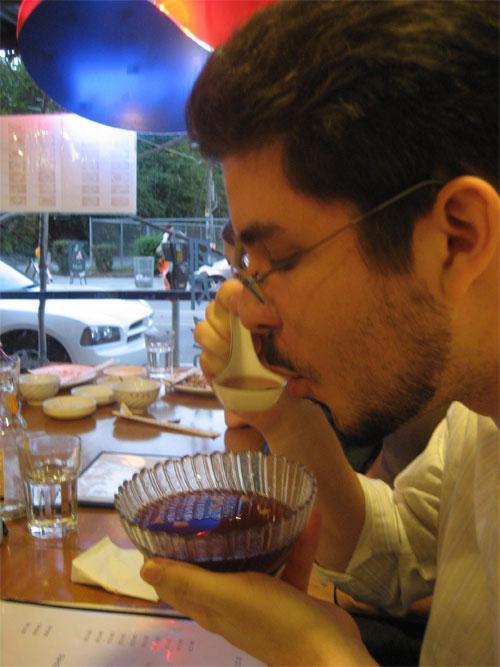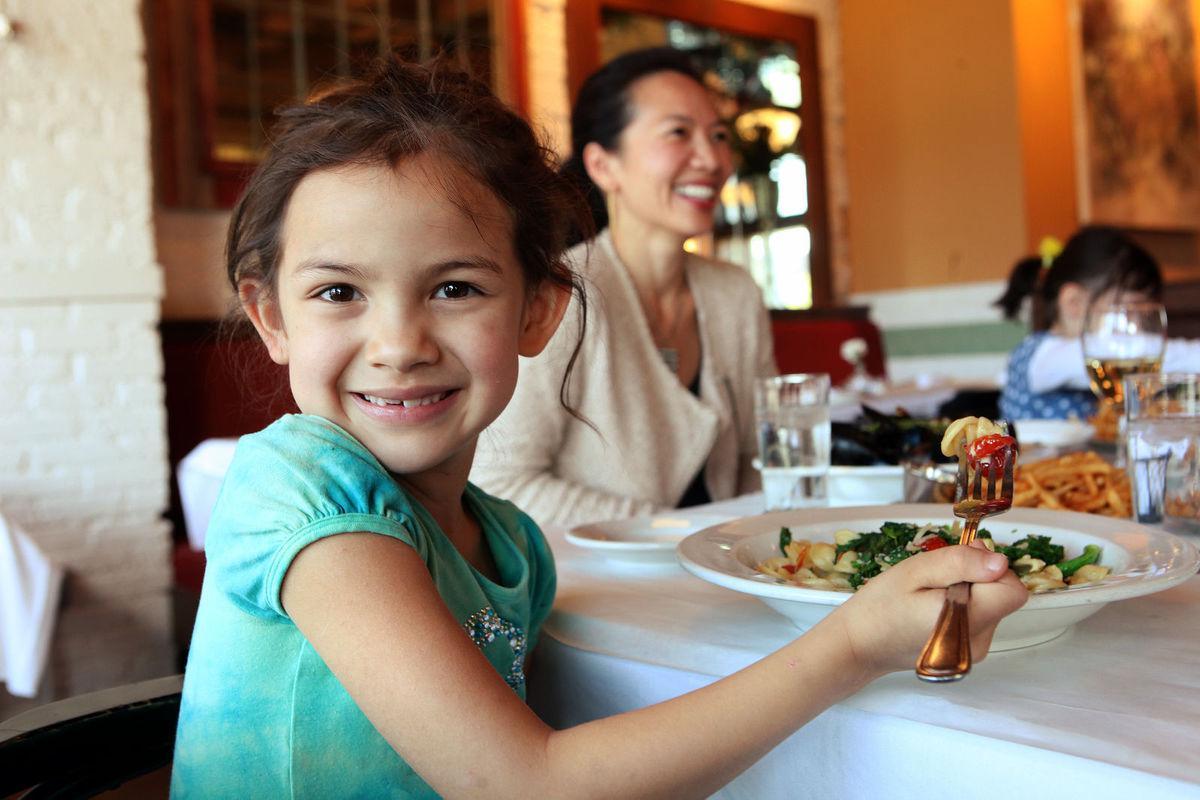The first image is the image on the left, the second image is the image on the right. For the images shown, is this caption "At least one of the pictures shows a person holding a fork or a spoon." true? Answer yes or no. Yes. The first image is the image on the left, the second image is the image on the right. For the images displayed, is the sentence "The left image shows a young man with dark hair on his head and facial hair, sitting behind a table and raising one hand to his mouth." factually correct? Answer yes or no. Yes. 